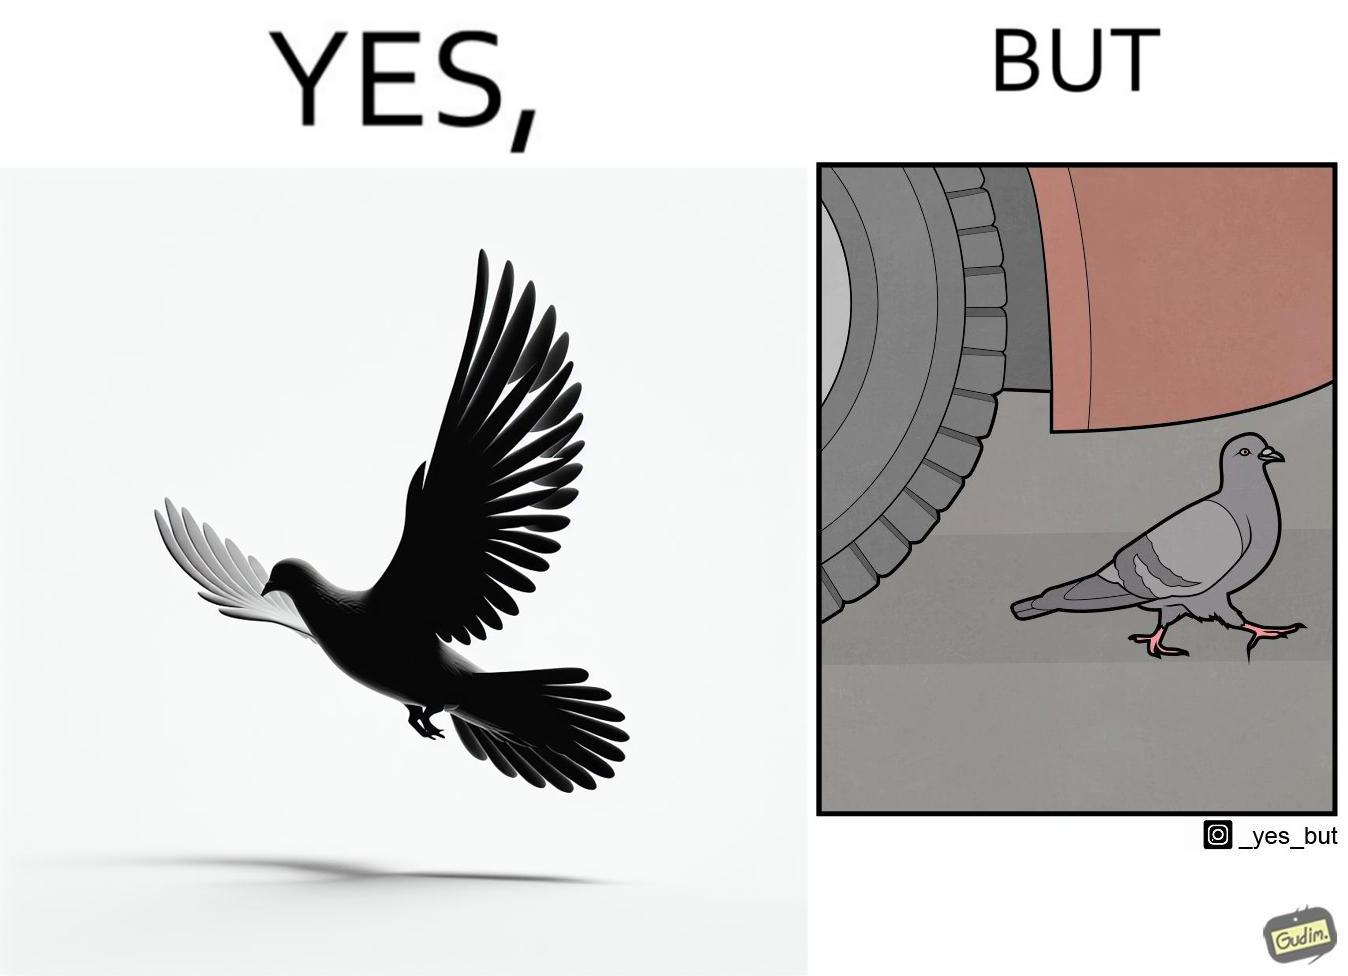Is this a satirical image? Yes, this image is satirical. 